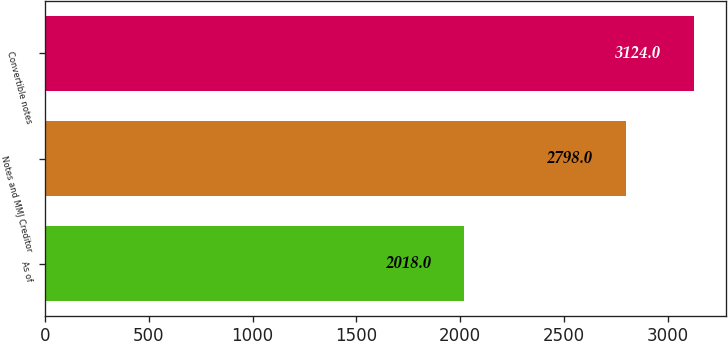<chart> <loc_0><loc_0><loc_500><loc_500><bar_chart><fcel>As of<fcel>Notes and MMJ Creditor<fcel>Convertible notes<nl><fcel>2018<fcel>2798<fcel>3124<nl></chart> 